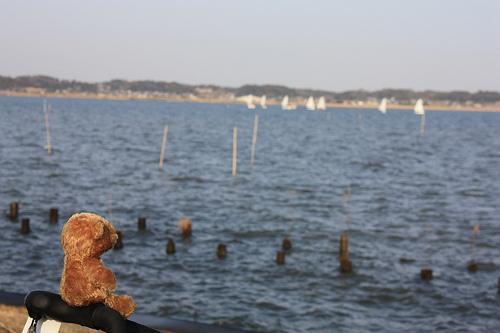How many bears are there?
Give a very brief answer. 1. 